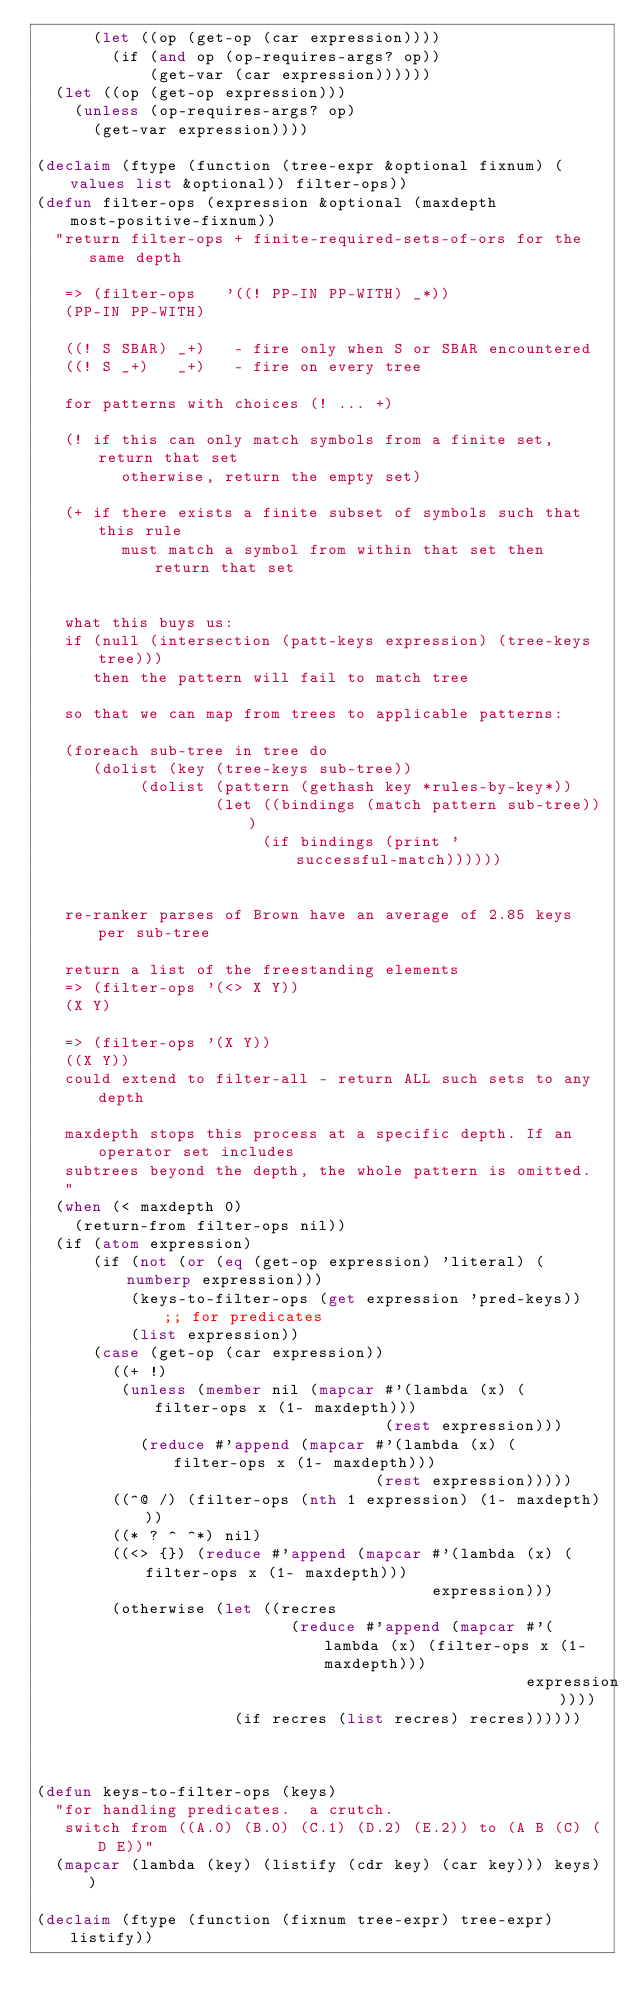Convert code to text. <code><loc_0><loc_0><loc_500><loc_500><_Lisp_>      (let ((op (get-op (car expression))))
        (if (and op (op-requires-args? op))
            (get-var (car expression))))))
  (let ((op (get-op expression)))
    (unless (op-requires-args? op)
      (get-var expression))))

(declaim (ftype (function (tree-expr &optional fixnum) (values list &optional)) filter-ops))
(defun filter-ops (expression &optional (maxdepth most-positive-fixnum))
  "return filter-ops + finite-required-sets-of-ors for the same depth

   => (filter-ops   '((! PP-IN PP-WITH) _*))
   (PP-IN PP-WITH)

   ((! S SBAR) _+)   - fire only when S or SBAR encountered
   ((! S _+)   _+)   - fire on every tree

   for patterns with choices (! ... +)

   (! if this can only match symbols from a finite set, return that set
         otherwise, return the empty set)

   (+ if there exists a finite subset of symbols such that this rule
         must match a symbol from within that set then return that set


   what this buys us:
   if (null (intersection (patt-keys expression) (tree-keys tree)))
      then the pattern will fail to match tree

   so that we can map from trees to applicable patterns:

   (foreach sub-tree in tree do
      (dolist (key (tree-keys sub-tree))
           (dolist (pattern (gethash key *rules-by-key*))
                   (let ((bindings (match pattern sub-tree)))
                        (if bindings (print 'successful-match))))))


   re-ranker parses of Brown have an average of 2.85 keys per sub-tree

   return a list of the freestanding elements
   => (filter-ops '(<> X Y))
   (X Y)

   => (filter-ops '(X Y))
   ((X Y))
   could extend to filter-all - return ALL such sets to any depth

   maxdepth stops this process at a specific depth. If an operator set includes
   subtrees beyond the depth, the whole pattern is omitted.
   "
  (when (< maxdepth 0)
    (return-from filter-ops nil))
  (if (atom expression)
      (if (not (or (eq (get-op expression) 'literal) (numberp expression)))
          (keys-to-filter-ops (get expression 'pred-keys))  ;; for predicates
          (list expression))
      (case (get-op (car expression))
        ((+ !)
         (unless (member nil (mapcar #'(lambda (x) (filter-ops x (1- maxdepth)))
                                     (rest expression)))
           (reduce #'append (mapcar #'(lambda (x) (filter-ops x (1- maxdepth)))
                                    (rest expression)))))
        ((^@ /) (filter-ops (nth 1 expression) (1- maxdepth)))
        ((* ? ^ ^*) nil)
        ((<> {}) (reduce #'append (mapcar #'(lambda (x) (filter-ops x (1- maxdepth)))
                                          expression)))
        (otherwise (let ((recres
                           (reduce #'append (mapcar #'(lambda (x) (filter-ops x (1- maxdepth)))
                                                    expression))))
                     (if recres (list recres) recres))))))



(defun keys-to-filter-ops (keys)
  "for handling predicates.  a crutch.
   switch from ((A.0) (B.0) (C.1) (D.2) (E.2)) to (A B (C) (D E))"
  (mapcar (lambda (key) (listify (cdr key) (car key))) keys))

(declaim (ftype (function (fixnum tree-expr) tree-expr) listify))</code> 